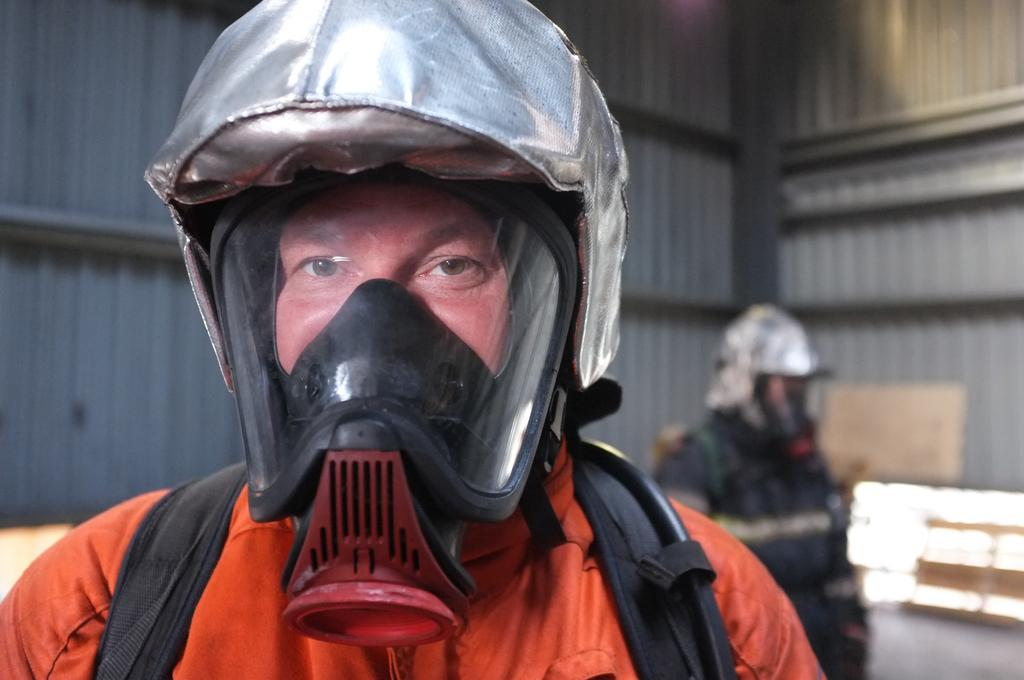What is the man in the image wearing over his face? The man is wearing a mask and a jacket over his face. Are there any other people in the image wearing masks? Yes, there is another person in the image wearing a mask. What is the position of the second person in the image? The second person is standing. What can be seen in the background of the image? There is a wall visible in the image. What type of pen is the man using to draw on the wall in the image? There is no pen or drawing activity present in the image. 